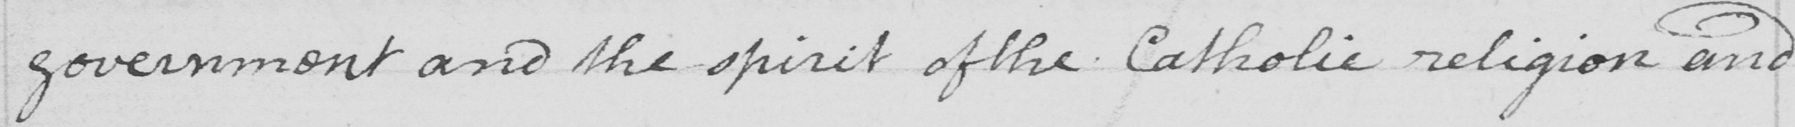Can you tell me what this handwritten text says? government and the spirit of the Catholic religion and 